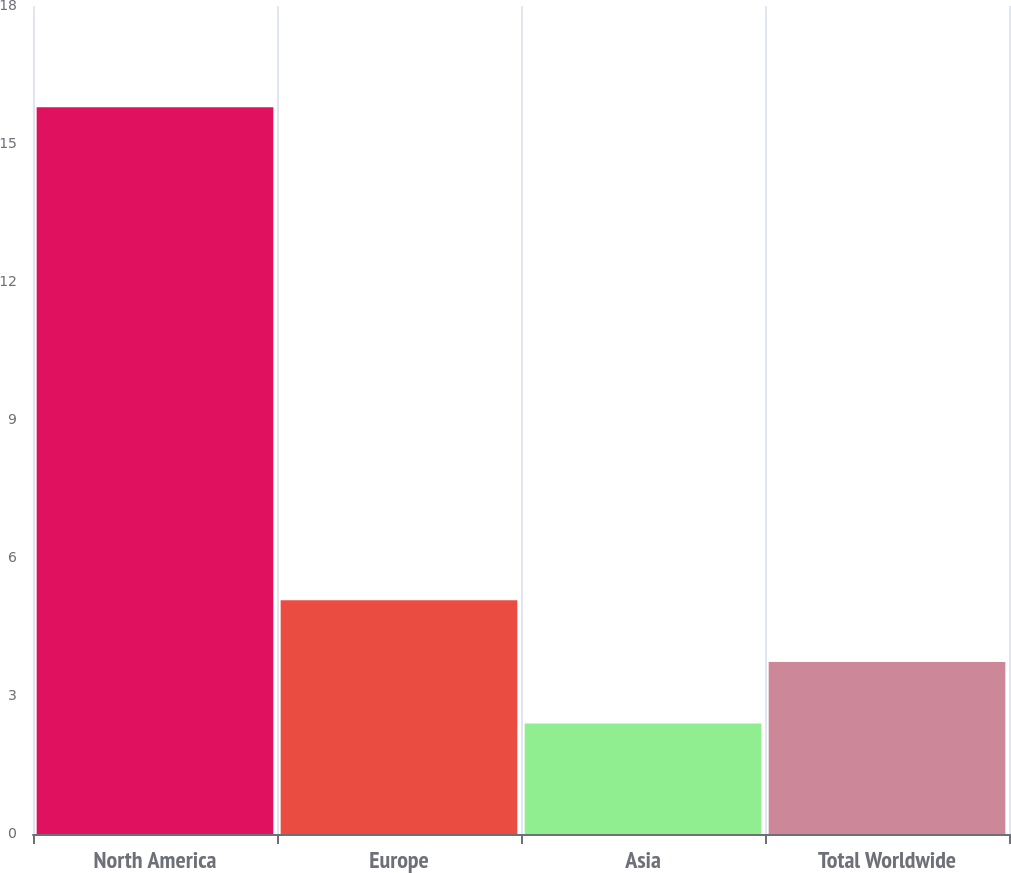Convert chart to OTSL. <chart><loc_0><loc_0><loc_500><loc_500><bar_chart><fcel>North America<fcel>Europe<fcel>Asia<fcel>Total Worldwide<nl><fcel>15.8<fcel>5.08<fcel>2.4<fcel>3.74<nl></chart> 